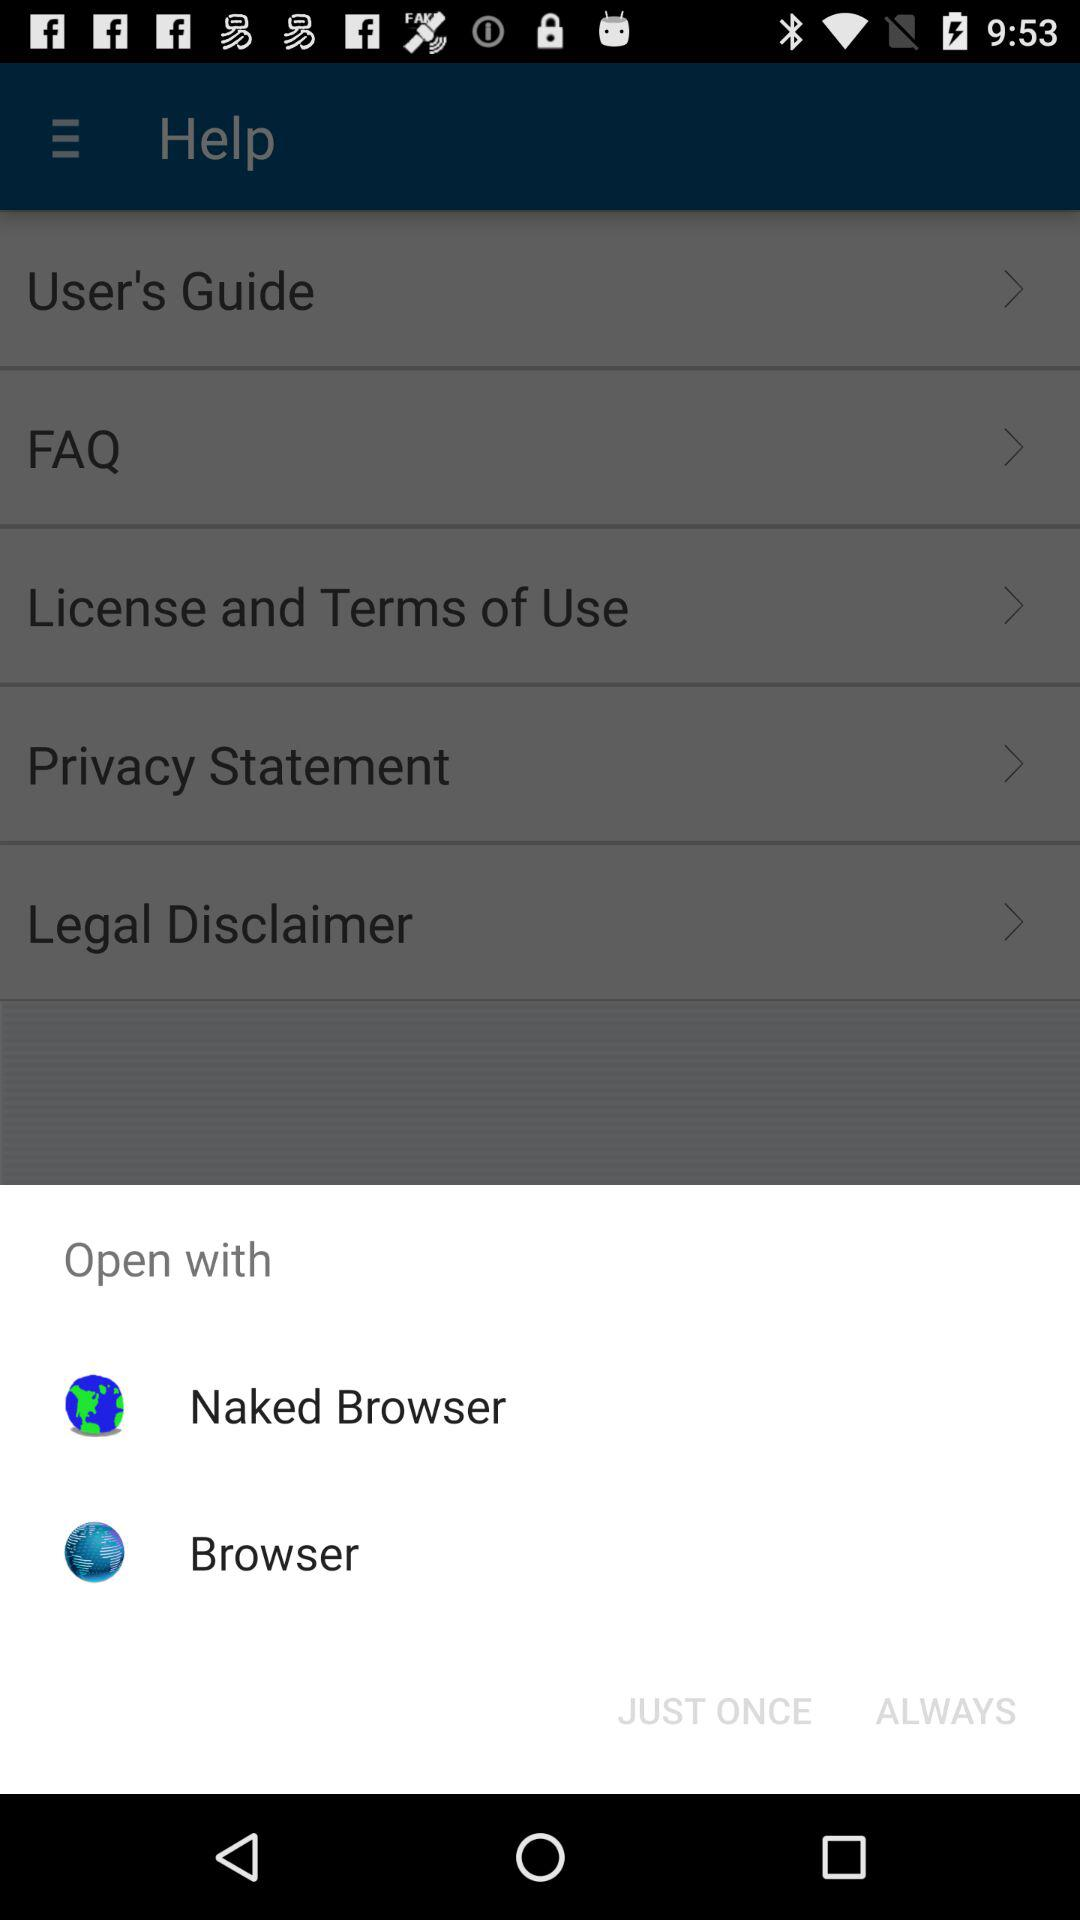How many of the links are about privacy?
Answer the question using a single word or phrase. 2 